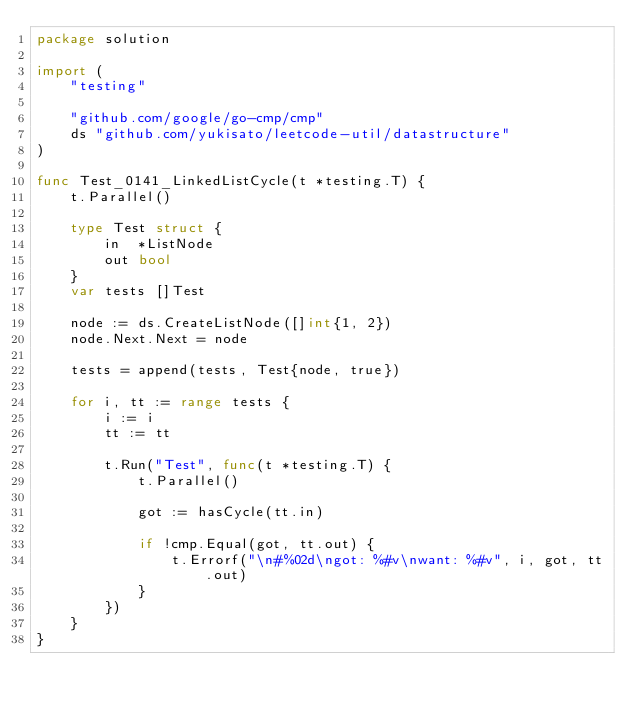<code> <loc_0><loc_0><loc_500><loc_500><_Go_>package solution

import (
	"testing"

	"github.com/google/go-cmp/cmp"
	ds "github.com/yukisato/leetcode-util/datastructure"
)

func Test_0141_LinkedListCycle(t *testing.T) {
	t.Parallel()

	type Test struct {
		in  *ListNode
		out bool
	}
	var tests []Test

	node := ds.CreateListNode([]int{1, 2})
	node.Next.Next = node

	tests = append(tests, Test{node, true})

	for i, tt := range tests {
		i := i
		tt := tt

		t.Run("Test", func(t *testing.T) {
			t.Parallel()

			got := hasCycle(tt.in)

			if !cmp.Equal(got, tt.out) {
				t.Errorf("\n#%02d\ngot: %#v\nwant: %#v", i, got, tt.out)
			}
		})
	}
}
</code> 